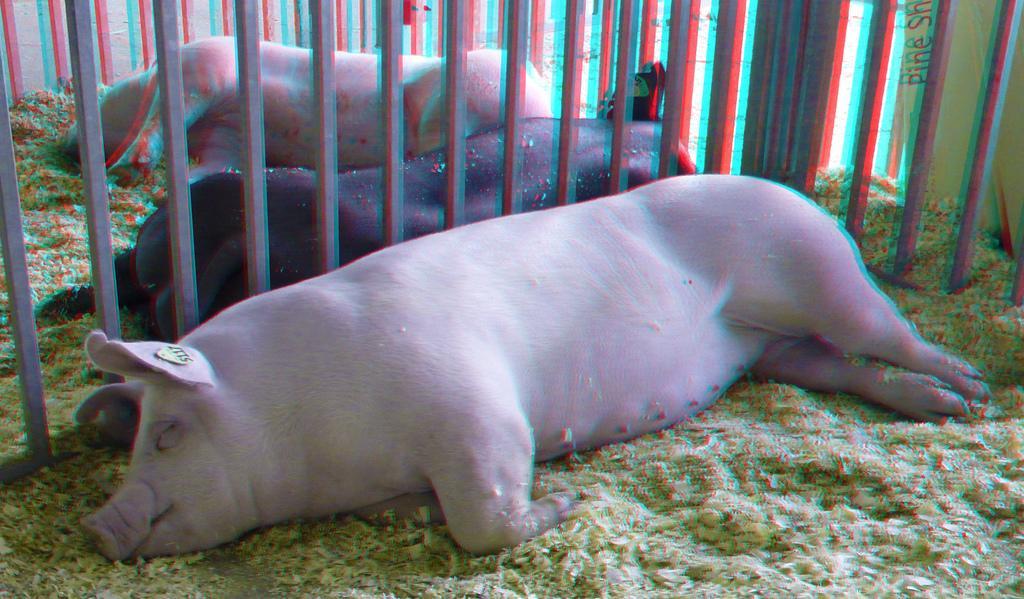Could you give a brief overview of what you see in this image? It is an edited image, there are three pigs kept in a cage and the pigs were laying on the ground. 